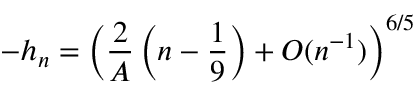<formula> <loc_0><loc_0><loc_500><loc_500>- h _ { n } = \left ( \frac { 2 } { A } \left ( n - \frac { 1 } { 9 } \right ) + O ( n ^ { - 1 } ) \right ) ^ { 6 / 5 }</formula> 